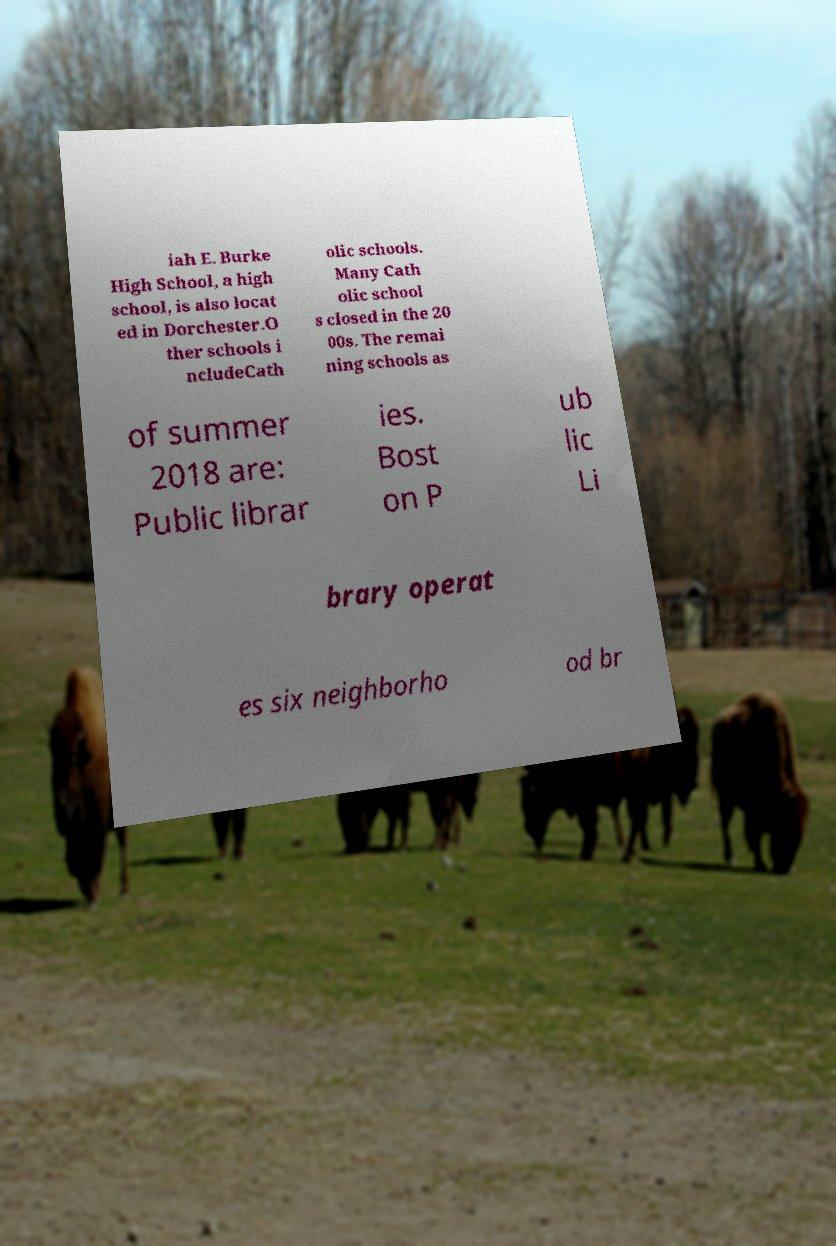Could you extract and type out the text from this image? iah E. Burke High School, a high school, is also locat ed in Dorchester.O ther schools i ncludeCath olic schools. Many Cath olic school s closed in the 20 00s. The remai ning schools as of summer 2018 are: Public librar ies. Bost on P ub lic Li brary operat es six neighborho od br 